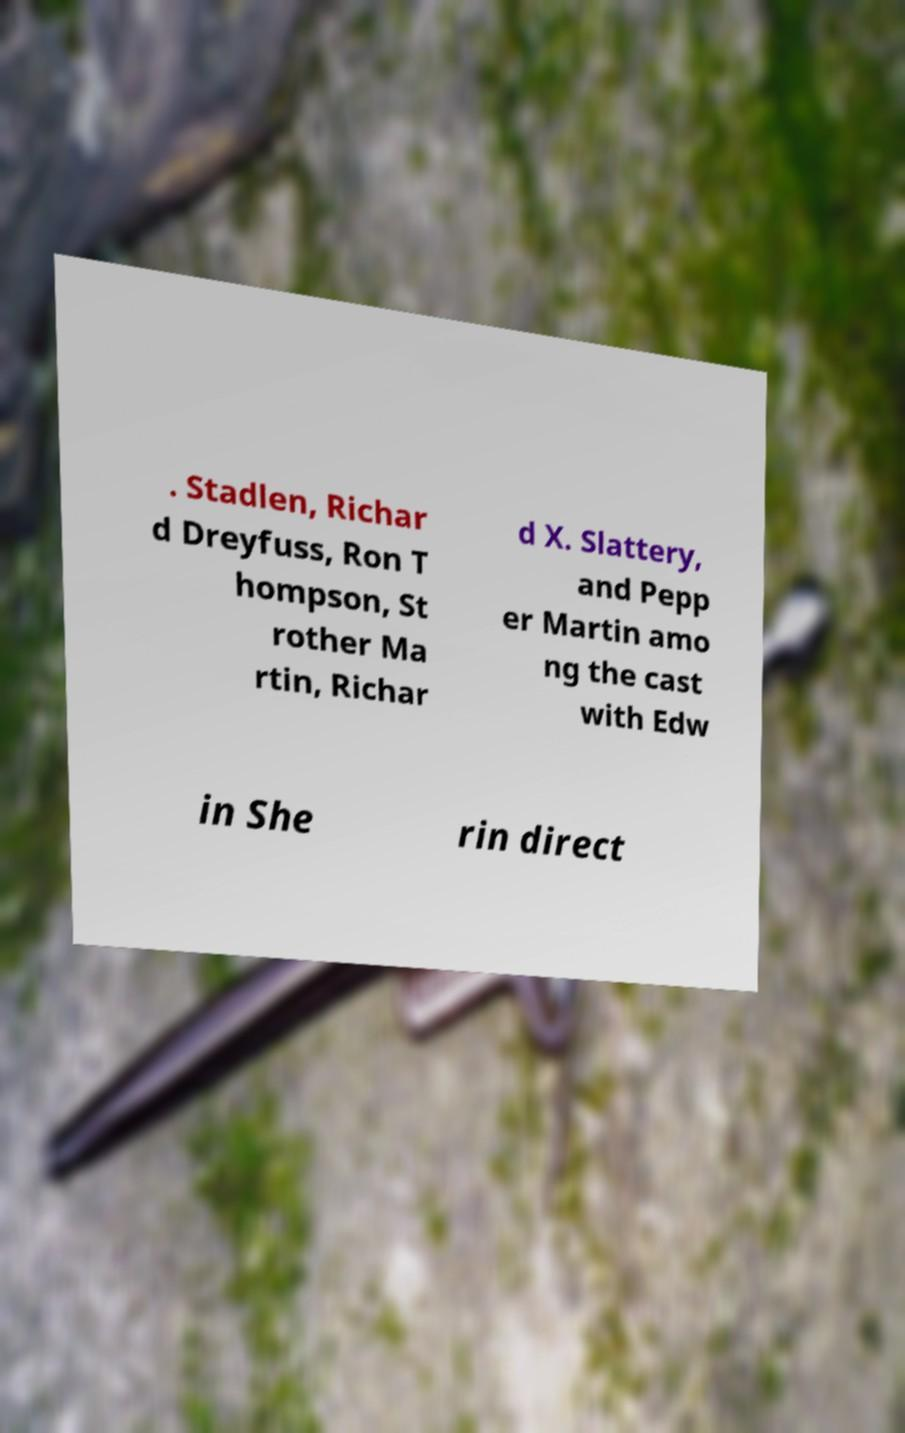What messages or text are displayed in this image? I need them in a readable, typed format. . Stadlen, Richar d Dreyfuss, Ron T hompson, St rother Ma rtin, Richar d X. Slattery, and Pepp er Martin amo ng the cast with Edw in She rin direct 